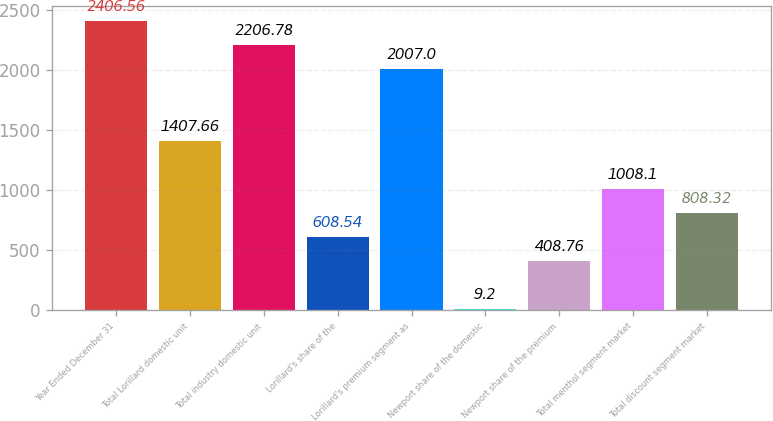<chart> <loc_0><loc_0><loc_500><loc_500><bar_chart><fcel>Year Ended December 31<fcel>Total Lorillard domestic unit<fcel>Total industry domestic unit<fcel>Lorillard's share of the<fcel>Lorillard's premium segment as<fcel>Newport share of the domestic<fcel>Newport share of the premium<fcel>Total menthol segment market<fcel>Total discount segment market<nl><fcel>2406.56<fcel>1407.66<fcel>2206.78<fcel>608.54<fcel>2007<fcel>9.2<fcel>408.76<fcel>1008.1<fcel>808.32<nl></chart> 